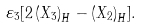Convert formula to latex. <formula><loc_0><loc_0><loc_500><loc_500>\varepsilon _ { 3 } [ 2 \left ( X _ { 3 } \right ) _ { H } - \left ( X _ { 2 } \right ) _ { H } ] .</formula> 